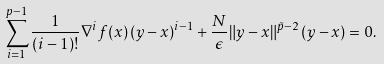<formula> <loc_0><loc_0><loc_500><loc_500>\sum _ { i = 1 } ^ { p - 1 } \frac { 1 } { ( i - 1 ) ! } \nabla ^ { i } f ( x ) \, ( y - x ) ^ { i - 1 } + \frac { N } { \epsilon } \| y - x \| ^ { \tilde { p } - 2 } \, ( y - x ) = 0 .</formula> 